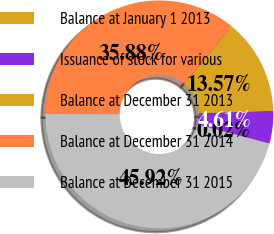Convert chart to OTSL. <chart><loc_0><loc_0><loc_500><loc_500><pie_chart><fcel>Balance at January 1 2013<fcel>Issuance of stock for various<fcel>Balance at December 31 2013<fcel>Balance at December 31 2014<fcel>Balance at December 31 2015<nl><fcel>0.02%<fcel>4.61%<fcel>13.57%<fcel>35.88%<fcel>45.92%<nl></chart> 